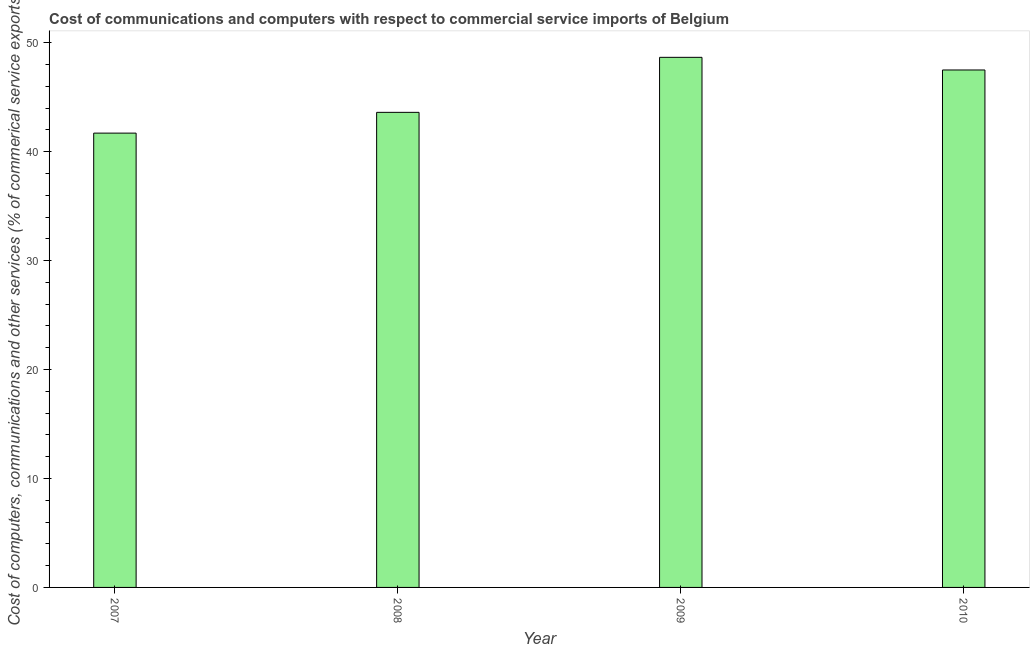What is the title of the graph?
Offer a terse response. Cost of communications and computers with respect to commercial service imports of Belgium. What is the label or title of the Y-axis?
Ensure brevity in your answer.  Cost of computers, communications and other services (% of commerical service exports). What is the cost of communications in 2009?
Make the answer very short. 48.66. Across all years, what is the maximum  computer and other services?
Your response must be concise. 48.66. Across all years, what is the minimum  computer and other services?
Your answer should be very brief. 41.71. In which year was the cost of communications minimum?
Your answer should be very brief. 2007. What is the sum of the cost of communications?
Offer a terse response. 181.48. What is the difference between the cost of communications in 2007 and 2010?
Provide a succinct answer. -5.8. What is the average  computer and other services per year?
Make the answer very short. 45.37. What is the median cost of communications?
Offer a terse response. 45.56. In how many years, is the cost of communications greater than 38 %?
Your answer should be very brief. 4. Do a majority of the years between 2008 and 2009 (inclusive) have cost of communications greater than 6 %?
Offer a terse response. Yes. What is the ratio of the  computer and other services in 2009 to that in 2010?
Keep it short and to the point. 1.02. Is the  computer and other services in 2008 less than that in 2010?
Offer a terse response. Yes. What is the difference between the highest and the second highest cost of communications?
Keep it short and to the point. 1.16. What is the difference between the highest and the lowest  computer and other services?
Give a very brief answer. 6.96. How many bars are there?
Your response must be concise. 4. Are all the bars in the graph horizontal?
Provide a succinct answer. No. What is the Cost of computers, communications and other services (% of commerical service exports) of 2007?
Give a very brief answer. 41.71. What is the Cost of computers, communications and other services (% of commerical service exports) in 2008?
Your answer should be very brief. 43.61. What is the Cost of computers, communications and other services (% of commerical service exports) in 2009?
Offer a terse response. 48.66. What is the Cost of computers, communications and other services (% of commerical service exports) in 2010?
Your answer should be compact. 47.5. What is the difference between the Cost of computers, communications and other services (% of commerical service exports) in 2007 and 2008?
Keep it short and to the point. -1.91. What is the difference between the Cost of computers, communications and other services (% of commerical service exports) in 2007 and 2009?
Give a very brief answer. -6.96. What is the difference between the Cost of computers, communications and other services (% of commerical service exports) in 2007 and 2010?
Ensure brevity in your answer.  -5.8. What is the difference between the Cost of computers, communications and other services (% of commerical service exports) in 2008 and 2009?
Your response must be concise. -5.05. What is the difference between the Cost of computers, communications and other services (% of commerical service exports) in 2008 and 2010?
Your answer should be very brief. -3.89. What is the difference between the Cost of computers, communications and other services (% of commerical service exports) in 2009 and 2010?
Offer a very short reply. 1.16. What is the ratio of the Cost of computers, communications and other services (% of commerical service exports) in 2007 to that in 2008?
Offer a terse response. 0.96. What is the ratio of the Cost of computers, communications and other services (% of commerical service exports) in 2007 to that in 2009?
Offer a very short reply. 0.86. What is the ratio of the Cost of computers, communications and other services (% of commerical service exports) in 2007 to that in 2010?
Provide a succinct answer. 0.88. What is the ratio of the Cost of computers, communications and other services (% of commerical service exports) in 2008 to that in 2009?
Offer a very short reply. 0.9. What is the ratio of the Cost of computers, communications and other services (% of commerical service exports) in 2008 to that in 2010?
Provide a succinct answer. 0.92. 